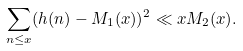<formula> <loc_0><loc_0><loc_500><loc_500>\sum _ { n \leq x } ( h ( n ) - M _ { 1 } ( x ) ) ^ { 2 } \ll x M _ { 2 } ( x ) .</formula> 